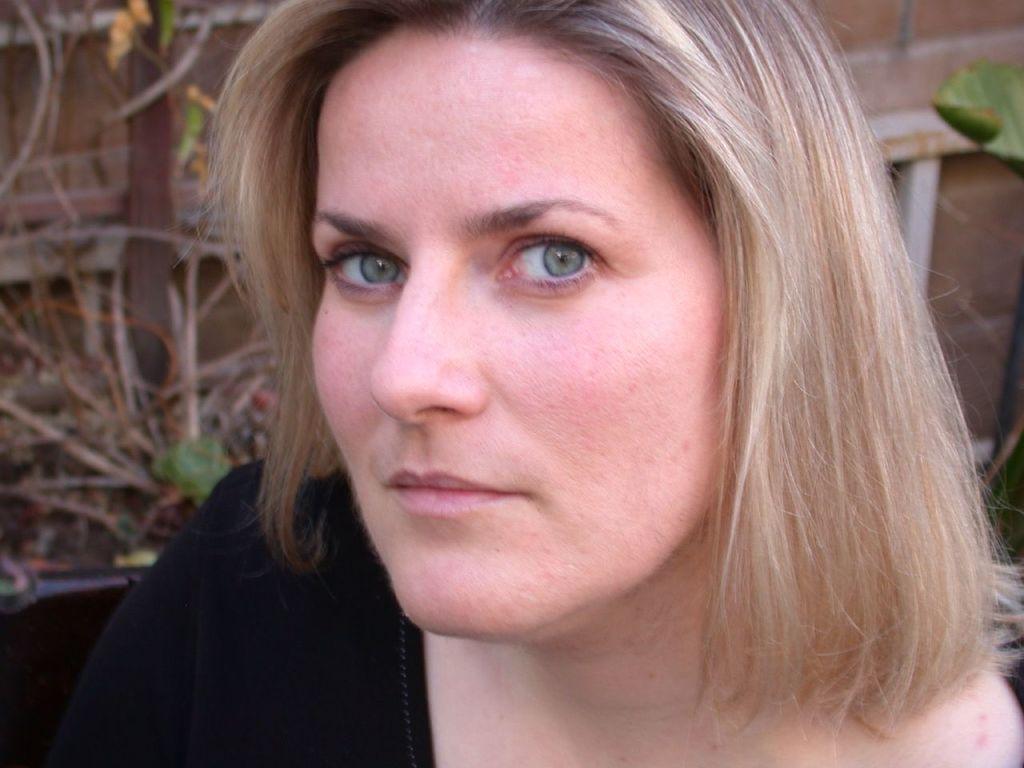In one or two sentences, can you explain what this image depicts? In this image, we can see a woman in black dress is watching. Background we can see wall. Here can see leaf, rods and few objects. 